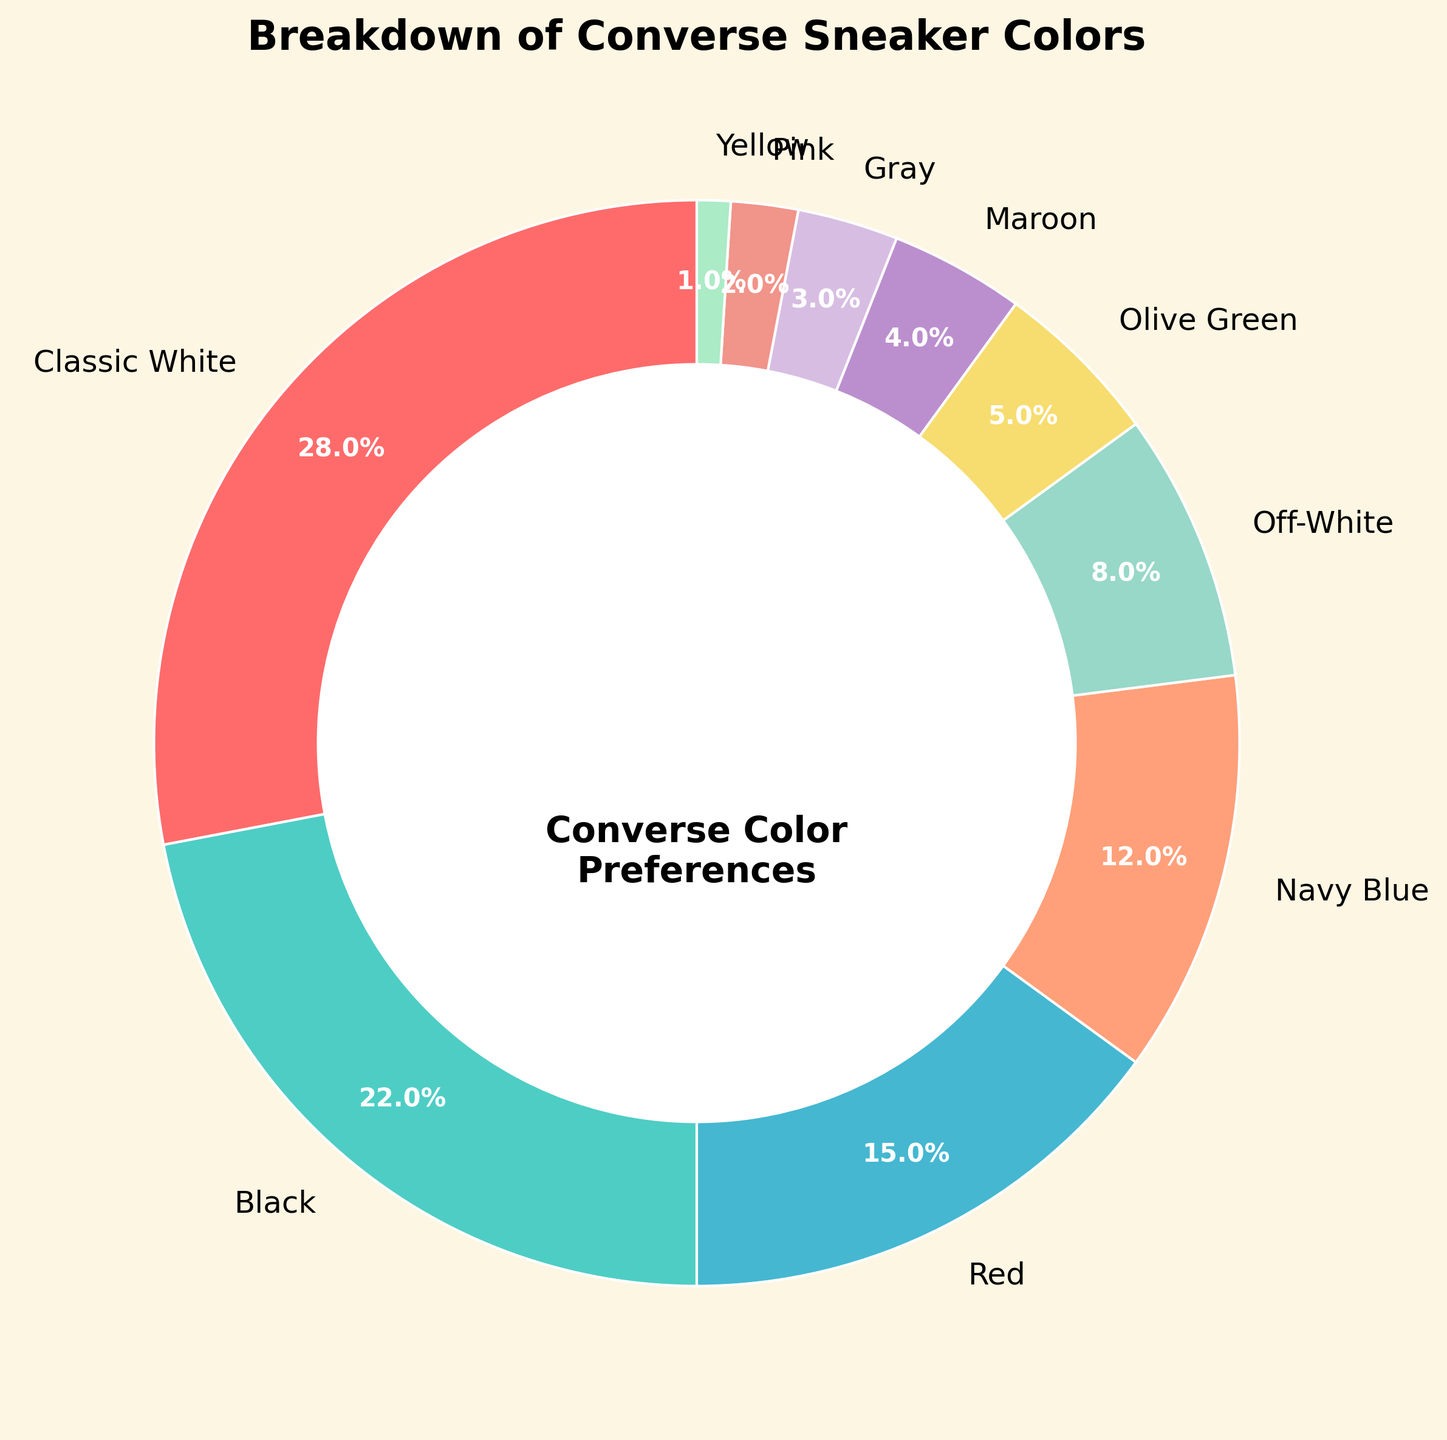Which color is the most preferred by customers? The size of each wedge in the pie chart represents the percentage of preferences for each color. The largest wedge corresponds to "Classic White" with 28%.
Answer: Classic White Which color is least preferred by customers? The smallest wedge in the pie chart represents the color with the least preference. This is "Yellow" with 1%.
Answer: Yellow How many colors have a preference percentage of above 20%? Observing the labels in the pie chart, "Classic White" (28%) and "Black" (22%) are the only colors above 20%. There are 2 such colors.
Answer: 2 What is the total percentage of customers that prefer either Navy Blue or Red sneakers? Adding the percentages for Navy Blue (12%) and Red (15%), we get 12% + 15% = 27%.
Answer: 27% Are the combined preferences for Off-White and Olive Green greater than for Black? Adding the percentages for Off-White (8%) and Olive Green (5%) gives 8% + 5% = 13%, which is less than Black's 22%.
Answer: No Which color represents the exact midpoint in the preference distribution among the listed colors? Sorting percentages, the middle value in the ordered list of percentages is the median. The sorted preferences are [1, 2, 3, 4, 5, 8, 12, 15, 22, 28]. The median is between 8% and 12%, representing Off-White.
Answer: Off-White Are there more people who prefer Maroon or Olive Green? The pie chart shows Maroon with 4% and Olive Green with 5%, so more people prefer Olive Green.
Answer: Olive Green Which colors have a percentage difference of exactly 10%? By comparing the percentages, "Classic White" (28%) and "Black" (22%) have a difference of 6%. No two colors have exactly a 10% difference.
Answer: None What is the total percentage of customers who prefer non-neutral colors (i.e., excluding Classic White, Black, Off-White, and Gray)? Summing percentages of Red (15%), Navy Blue (12%), Olive Green (5%), Maroon (4%), Pink (2%), and Yellow (1%) equals 39%.
Answer: 39% Which color's wedge is the fourth largest in the pie chart? After sorting, the fourth largest percentage represents "Navy Blue" with 12%.
Answer: Navy Blue 